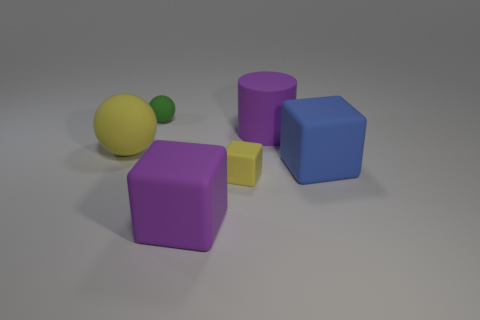Add 3 cyan shiny cylinders. How many objects exist? 9 Subtract all cylinders. How many objects are left? 5 Add 6 blue objects. How many blue objects are left? 7 Add 3 large yellow balls. How many large yellow balls exist? 4 Subtract 1 blue cubes. How many objects are left? 5 Subtract all big blue rubber cubes. Subtract all small blue balls. How many objects are left? 5 